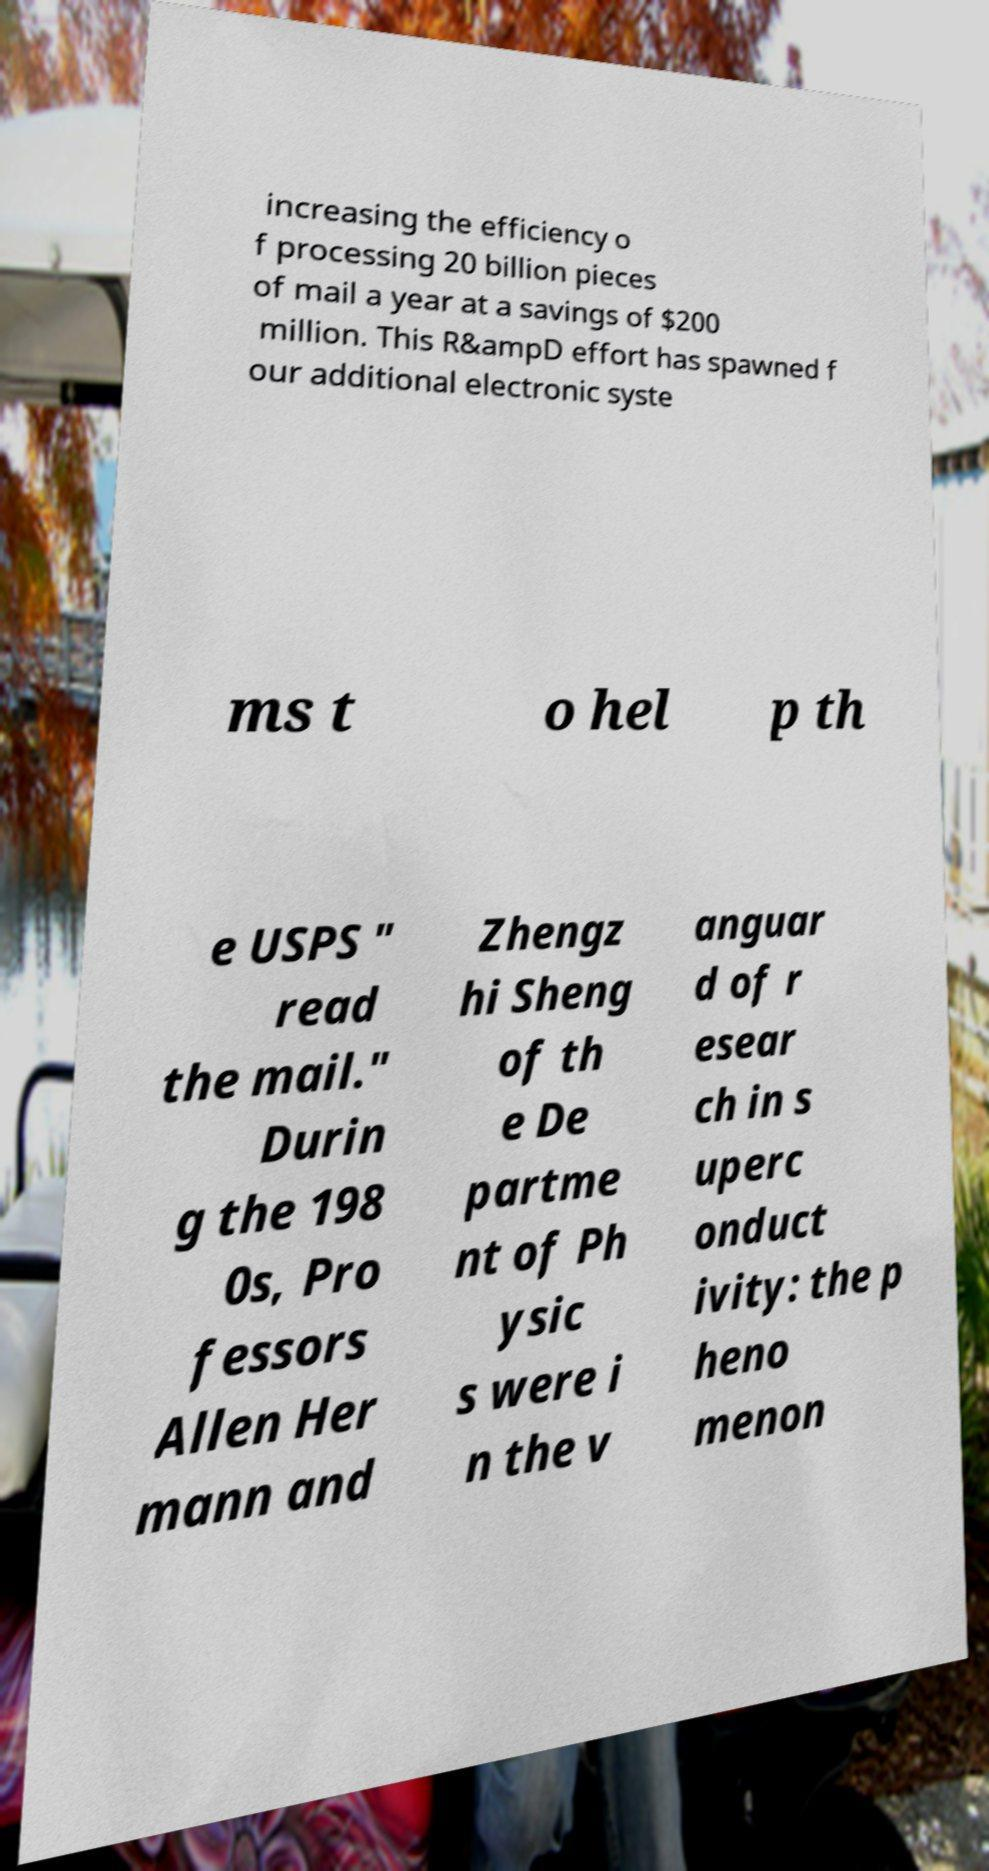Can you accurately transcribe the text from the provided image for me? increasing the efficiency o f processing 20 billion pieces of mail a year at a savings of $200 million. This R&ampD effort has spawned f our additional electronic syste ms t o hel p th e USPS " read the mail." Durin g the 198 0s, Pro fessors Allen Her mann and Zhengz hi Sheng of th e De partme nt of Ph ysic s were i n the v anguar d of r esear ch in s uperc onduct ivity: the p heno menon 